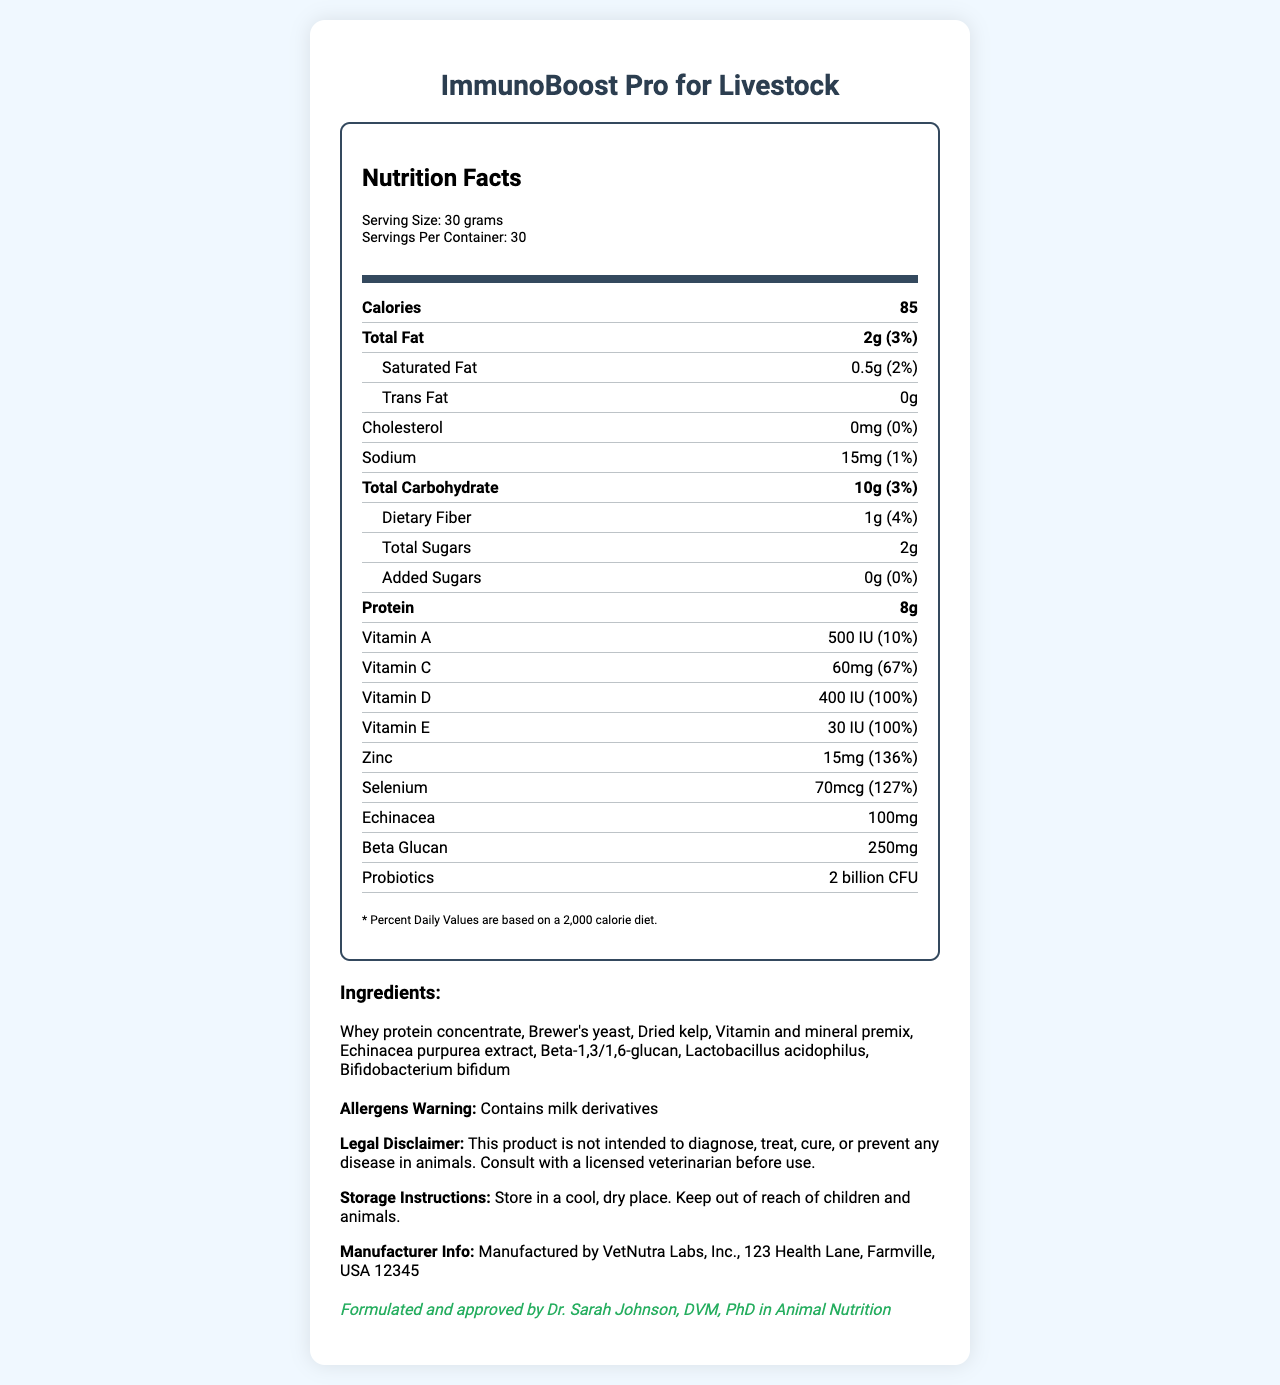what is the serving size for ImmunoBoost Pro for Livestock? The serving size is explicitly listed as "30 grams" under the serving information.
Answer: 30 grams how many calories are there per serving? The calories per serving are mentioned as 85 in the nutrition label.
Answer: 85 calories what is the percentage daily value of Vitamin D in this supplement? The percentage daily value of Vitamin D is stated as 100% in the nutrition label.
Answer: 100% how much sodium is in one serving of the supplement? The sodium content per serving is listed as 15 mg.
Answer: 15 mg what are the storage instructions for ImmunoBoost Pro for Livestock? The storage instructions are mentioned in the warnings section.
Answer: Store in a cool, dry place. Keep out of reach of children and animals. which ingredient is included in the supplement? A. Soy protein B. Whey protein concentrate C. Ground corn D. Chicken meal Whey protein concentrate is listed as an ingredient under the ingredients section.
Answer: B. Whey protein concentrate how much protein is in each serving? A. 5g B. 8g C. 10g D. 12g The protein content per serving is 8g according to the nutrition label.
Answer: B. 8g does this product contain added sugars? The added sugars are listed as 0g in the nutrition label.
Answer: No describe the main purpose of the ImmunoBoost Pro for Livestock supplement. The supplement is designed to boost immune function in livestock as detailed in the product description and the ingredients list that includes immune-supporting components like echinacea and beta-glucan.
Answer: To boost immune function in livestock with a combination of vitamins, minerals, probiotics, and other beneficial ingredients. what is the ingredient echinacea used for in this supplement? The document does not provide specific details about the purpose of each ingredient, only listing them.
Answer: Not enough information who approved the formulation of this product? The approval information is stated by Dr. Sarah Johnson in the vet-approval section.
Answer: Dr. Sarah Johnson, DVM, PhD in Animal Nutrition 